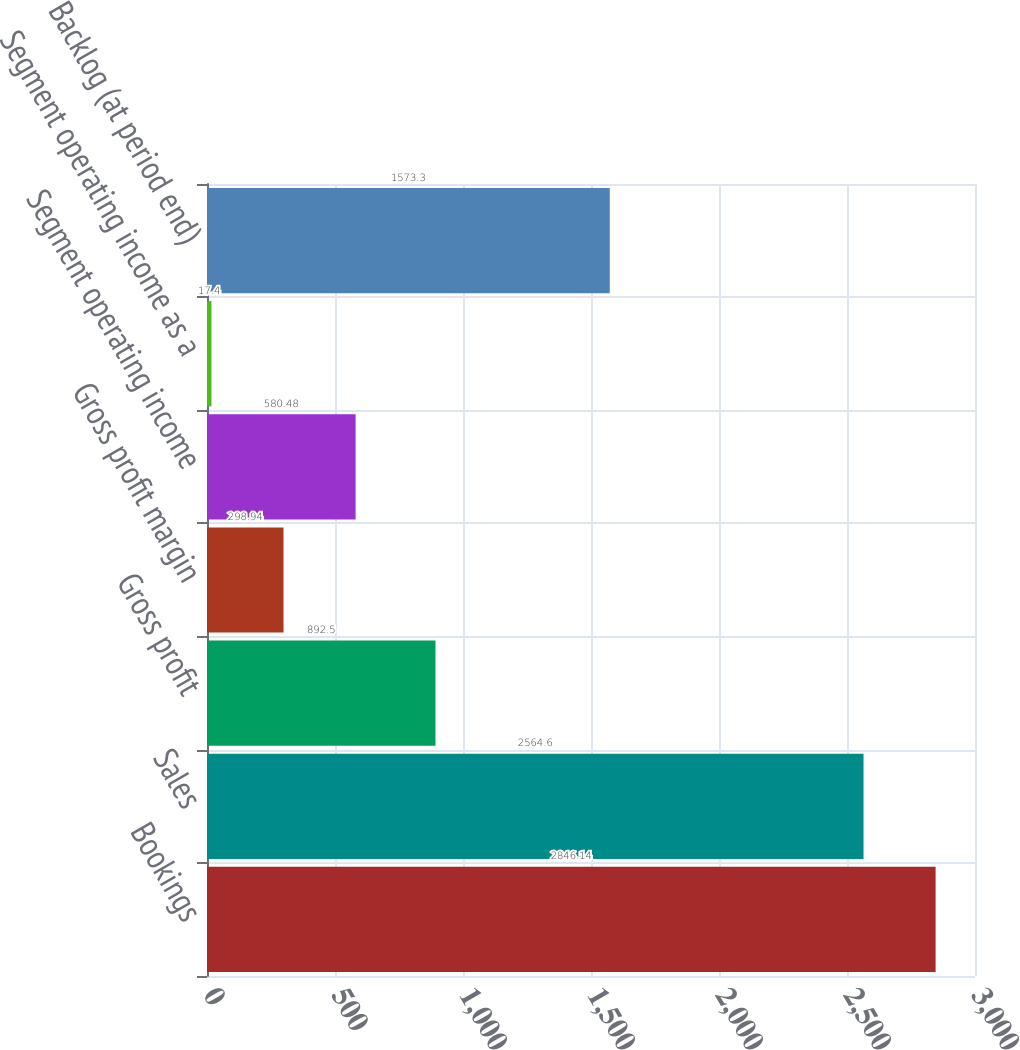Convert chart. <chart><loc_0><loc_0><loc_500><loc_500><bar_chart><fcel>Bookings<fcel>Sales<fcel>Gross profit<fcel>Gross profit margin<fcel>Segment operating income<fcel>Segment operating income as a<fcel>Backlog (at period end)<nl><fcel>2846.14<fcel>2564.6<fcel>892.5<fcel>298.94<fcel>580.48<fcel>17.4<fcel>1573.3<nl></chart> 